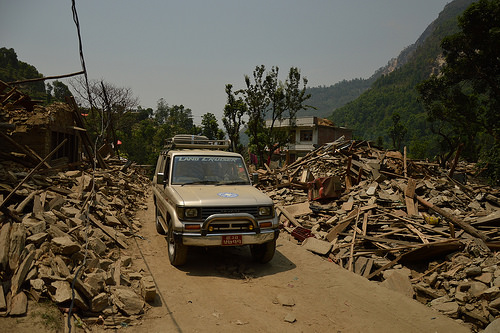<image>
Is the tree in front of the tree? No. The tree is not in front of the tree. The spatial positioning shows a different relationship between these objects. 